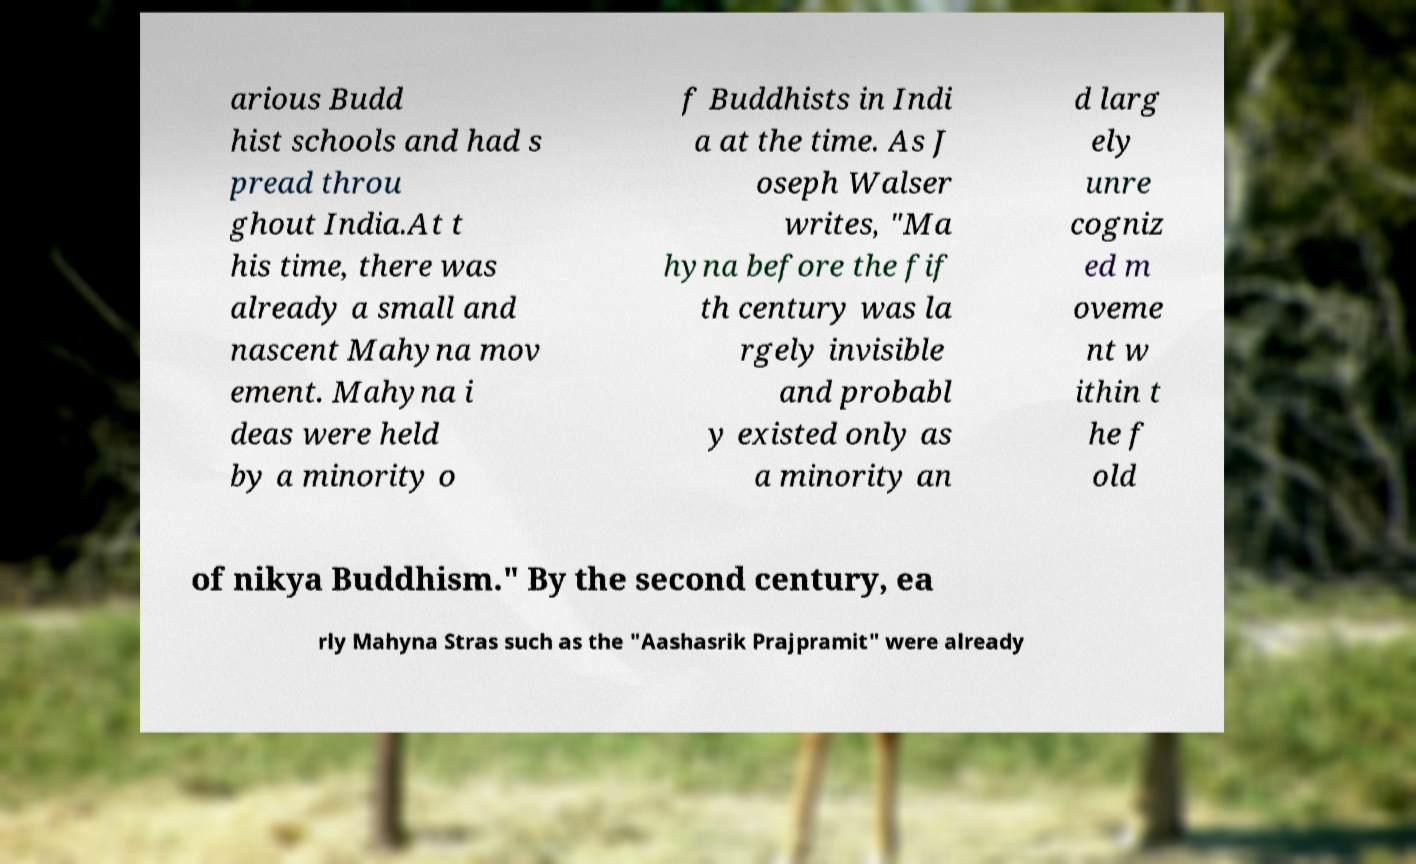Please identify and transcribe the text found in this image. arious Budd hist schools and had s pread throu ghout India.At t his time, there was already a small and nascent Mahyna mov ement. Mahyna i deas were held by a minority o f Buddhists in Indi a at the time. As J oseph Walser writes, "Ma hyna before the fif th century was la rgely invisible and probabl y existed only as a minority an d larg ely unre cogniz ed m oveme nt w ithin t he f old of nikya Buddhism." By the second century, ea rly Mahyna Stras such as the "Aashasrik Prajpramit" were already 